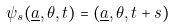<formula> <loc_0><loc_0><loc_500><loc_500>\psi _ { s } ( \underline { a } , \theta , t ) = ( \underline { a } , \theta , t + s )</formula> 